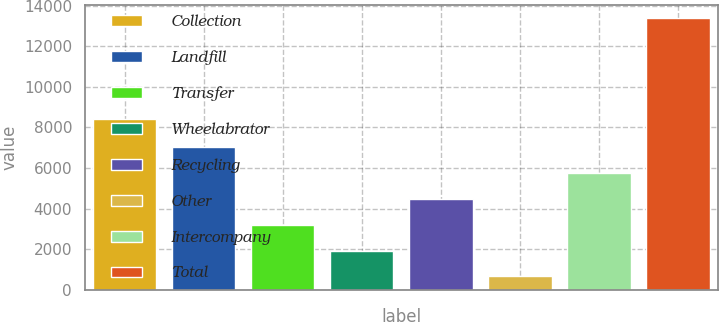<chart> <loc_0><loc_0><loc_500><loc_500><bar_chart><fcel>Collection<fcel>Landfill<fcel>Transfer<fcel>Wheelabrator<fcel>Recycling<fcel>Other<fcel>Intercompany<fcel>Total<nl><fcel>8406<fcel>7016.5<fcel>3199.6<fcel>1927.3<fcel>4471.9<fcel>655<fcel>5744.2<fcel>13378<nl></chart> 